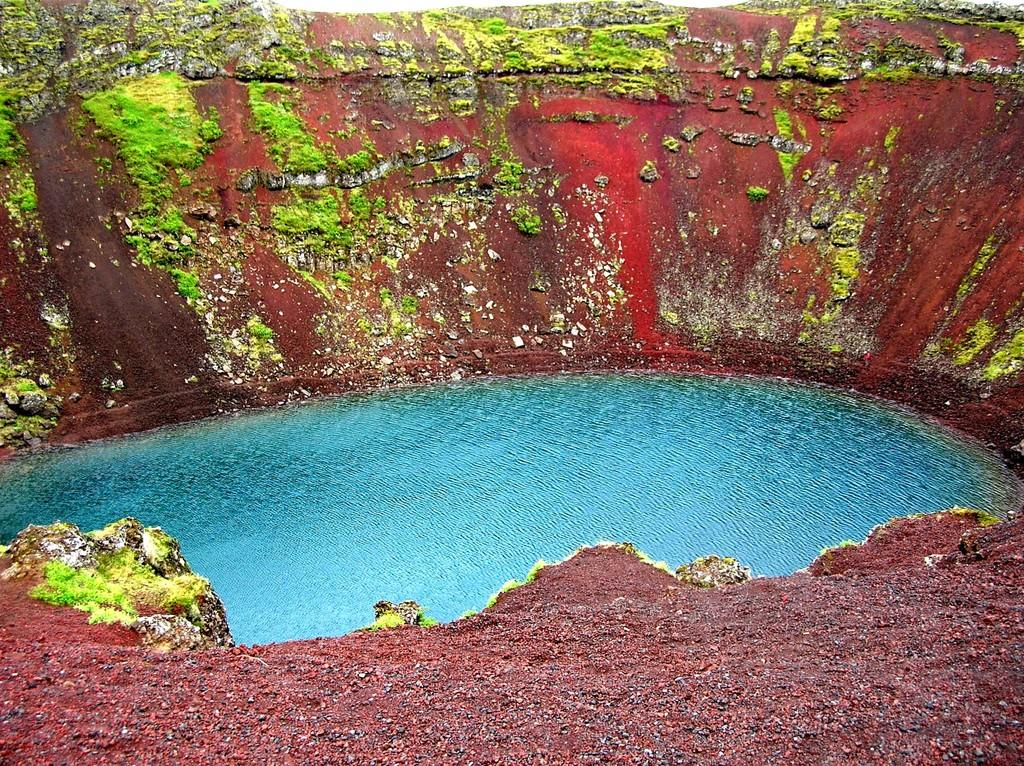What is the primary feature of the image? There is a pond with water in the image. What else can be seen in the image besides the pond? There is a wall in the image. Can you describe the condition of the wall? The wall has algae on it. What type of zinc is present in the image? There is no zinc present in the image. Can you tell me how many members are on the team in the image? There is no team present in the image. 